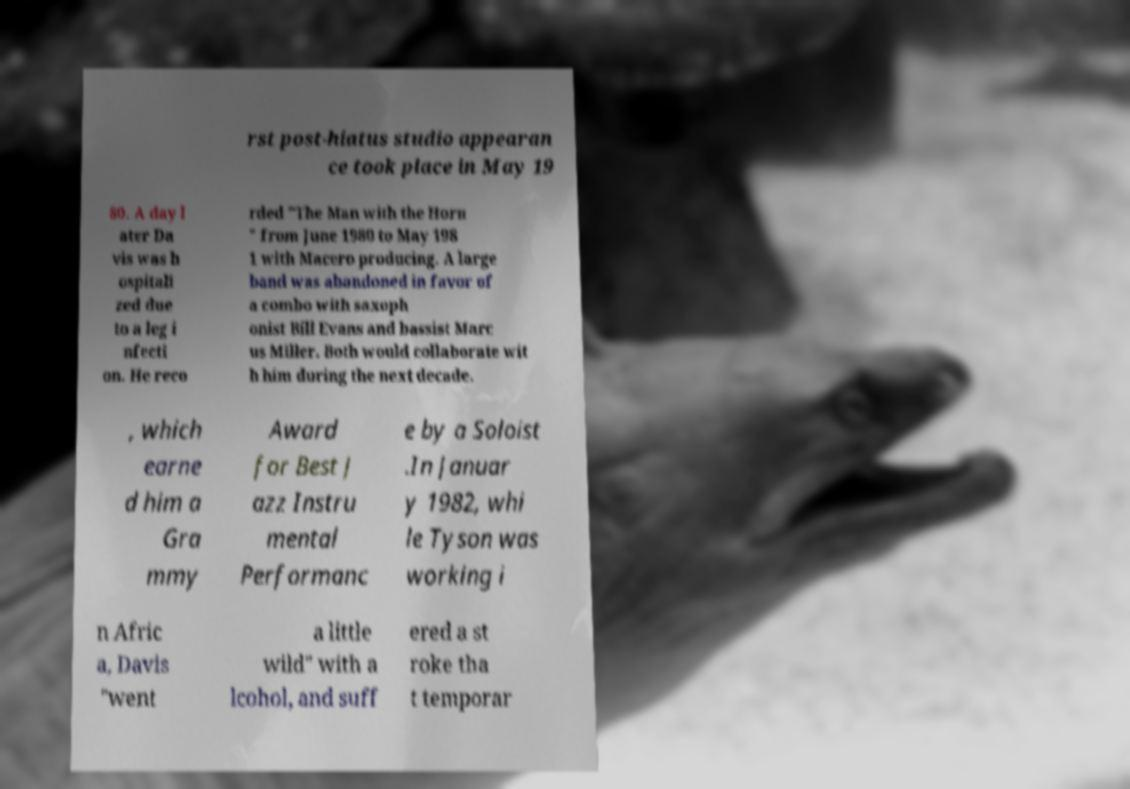Could you assist in decoding the text presented in this image and type it out clearly? rst post-hiatus studio appearan ce took place in May 19 80. A day l ater Da vis was h ospitali zed due to a leg i nfecti on. He reco rded "The Man with the Horn " from June 1980 to May 198 1 with Macero producing. A large band was abandoned in favor of a combo with saxoph onist Bill Evans and bassist Marc us Miller. Both would collaborate wit h him during the next decade. , which earne d him a Gra mmy Award for Best J azz Instru mental Performanc e by a Soloist .In Januar y 1982, whi le Tyson was working i n Afric a, Davis "went a little wild" with a lcohol, and suff ered a st roke tha t temporar 